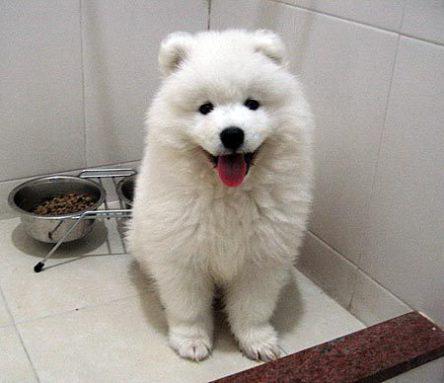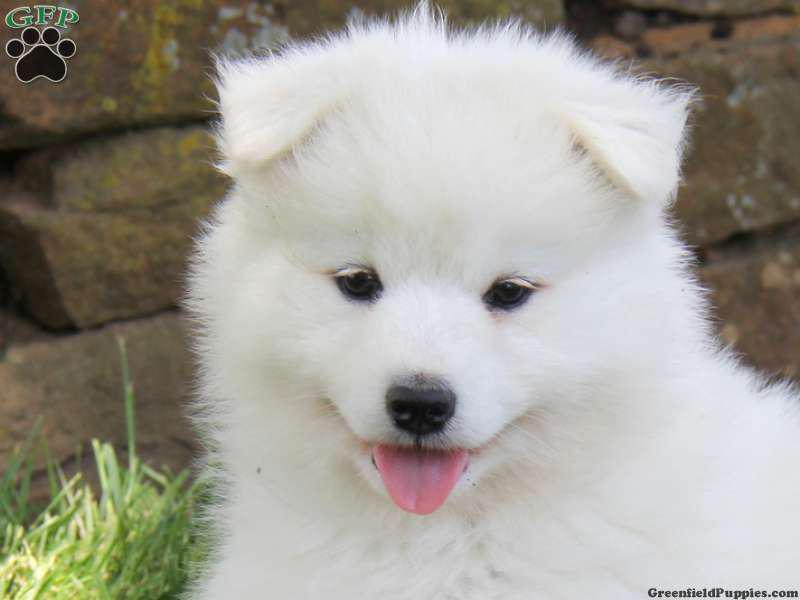The first image is the image on the left, the second image is the image on the right. For the images shown, is this caption "At least one image shows a white dog standing on all fours in the grass." true? Answer yes or no. No. The first image is the image on the left, the second image is the image on the right. Considering the images on both sides, is "The dog in the left photo has its tongue out." valid? Answer yes or no. Yes. 